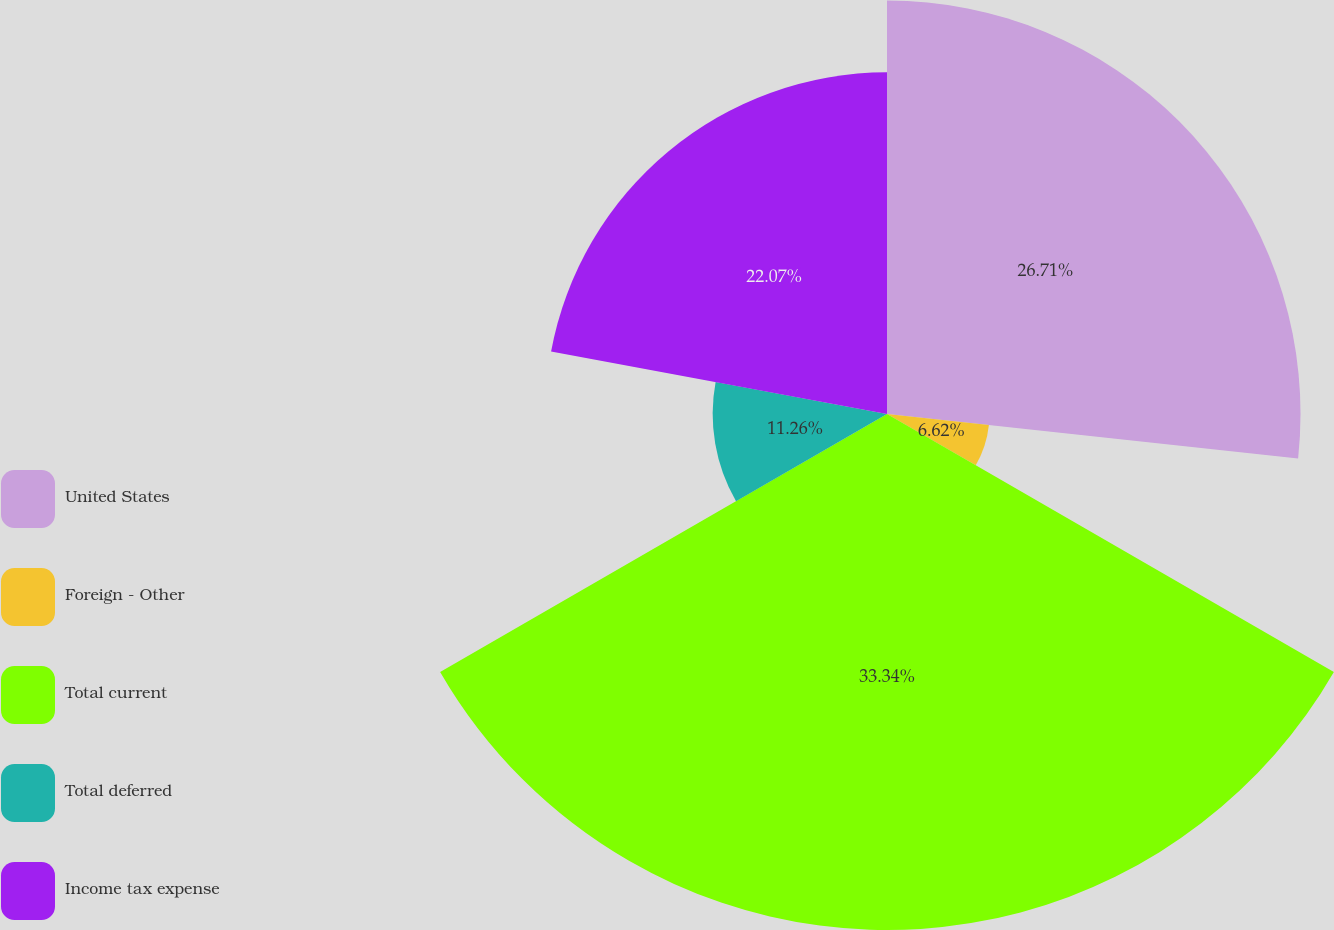Convert chart to OTSL. <chart><loc_0><loc_0><loc_500><loc_500><pie_chart><fcel>United States<fcel>Foreign - Other<fcel>Total current<fcel>Total deferred<fcel>Income tax expense<nl><fcel>26.71%<fcel>6.62%<fcel>33.33%<fcel>11.26%<fcel>22.07%<nl></chart> 